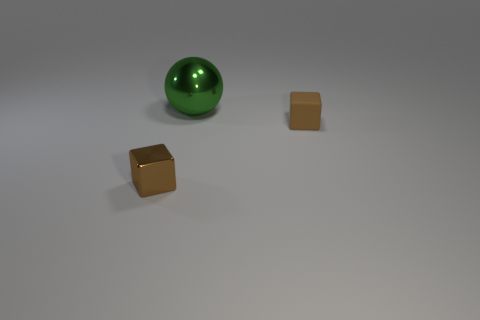There is another tiny block that is the same color as the matte cube; what is its material?
Offer a terse response. Metal. What is the color of the tiny shiny cube?
Your response must be concise. Brown. There is a small brown thing on the right side of the metallic cube; does it have the same shape as the brown shiny object?
Keep it short and to the point. Yes. What number of objects are small yellow metallic cylinders or small objects that are on the left side of the metallic sphere?
Your answer should be very brief. 1. Do the brown block in front of the matte cube and the big thing have the same material?
Your response must be concise. Yes. Is there anything else that has the same size as the green metal sphere?
Give a very brief answer. No. The tiny brown cube in front of the tiny brown thing right of the tiny metal thing is made of what material?
Give a very brief answer. Metal. Is the number of big metallic spheres behind the metallic sphere greater than the number of tiny rubber cubes to the right of the small rubber object?
Your response must be concise. No. How big is the metallic ball?
Ensure brevity in your answer.  Large. There is a metal object that is on the left side of the large metallic ball; is its color the same as the big object?
Make the answer very short. No. 